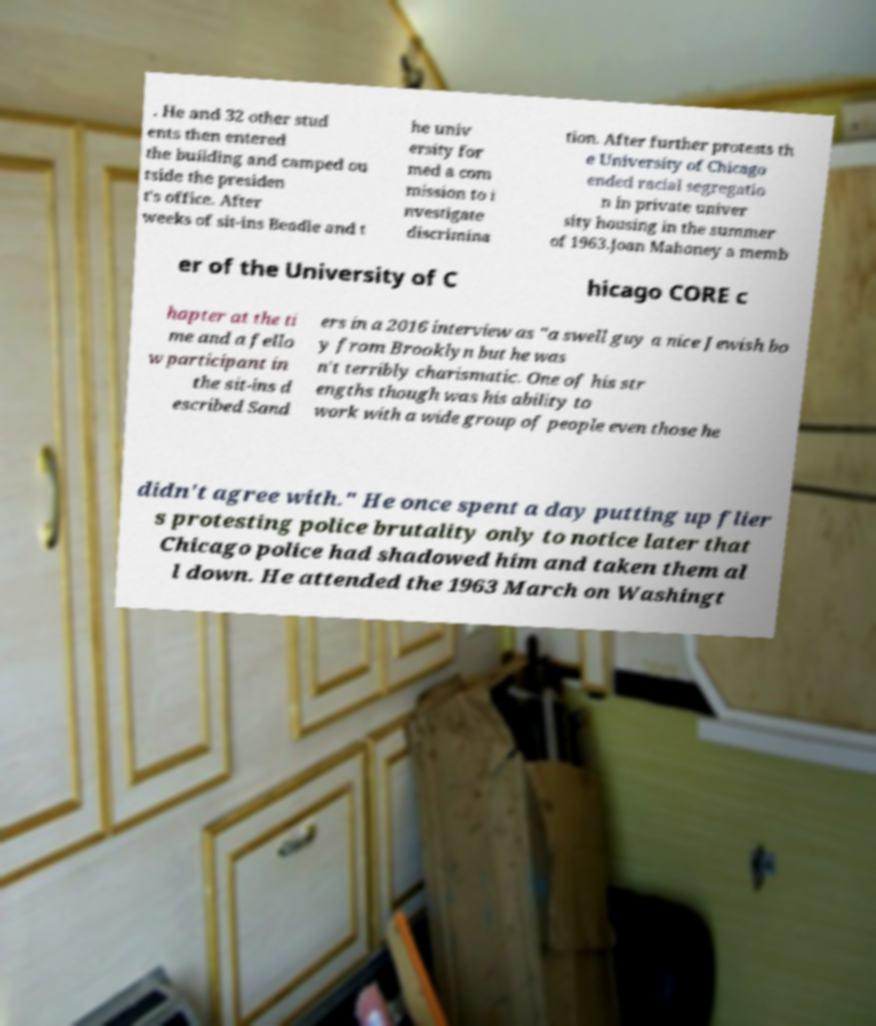There's text embedded in this image that I need extracted. Can you transcribe it verbatim? . He and 32 other stud ents then entered the building and camped ou tside the presiden t's office. After weeks of sit-ins Beadle and t he univ ersity for med a com mission to i nvestigate discrimina tion. After further protests th e University of Chicago ended racial segregatio n in private univer sity housing in the summer of 1963.Joan Mahoney a memb er of the University of C hicago CORE c hapter at the ti me and a fello w participant in the sit-ins d escribed Sand ers in a 2016 interview as "a swell guy a nice Jewish bo y from Brooklyn but he was n't terribly charismatic. One of his str engths though was his ability to work with a wide group of people even those he didn't agree with." He once spent a day putting up flier s protesting police brutality only to notice later that Chicago police had shadowed him and taken them al l down. He attended the 1963 March on Washingt 